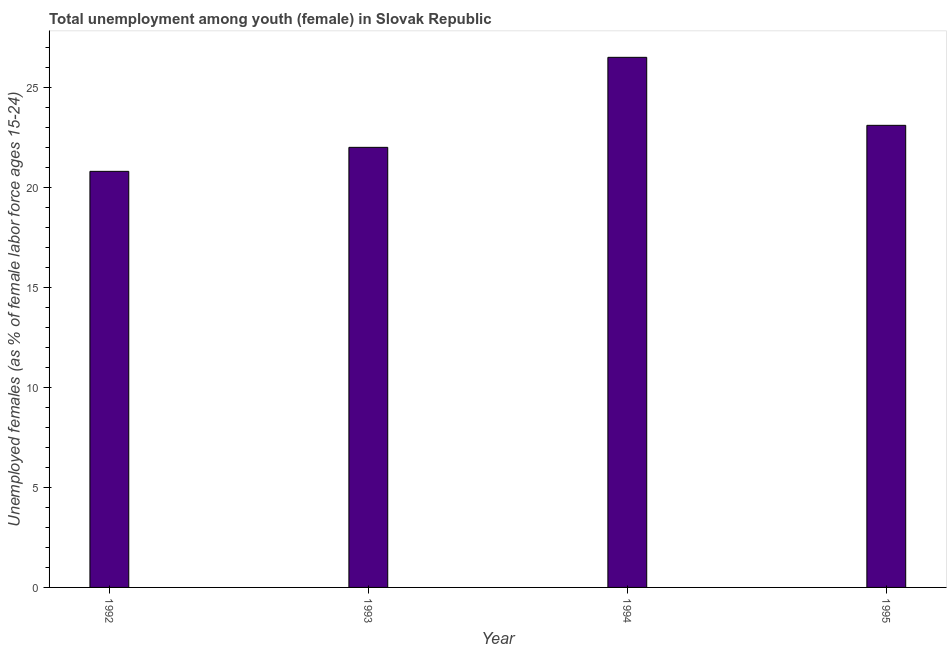Does the graph contain grids?
Provide a short and direct response. No. What is the title of the graph?
Your answer should be compact. Total unemployment among youth (female) in Slovak Republic. What is the label or title of the Y-axis?
Your answer should be compact. Unemployed females (as % of female labor force ages 15-24). What is the unemployed female youth population in 1992?
Offer a very short reply. 20.8. Across all years, what is the maximum unemployed female youth population?
Offer a terse response. 26.5. Across all years, what is the minimum unemployed female youth population?
Make the answer very short. 20.8. In which year was the unemployed female youth population maximum?
Make the answer very short. 1994. What is the sum of the unemployed female youth population?
Your response must be concise. 92.4. What is the average unemployed female youth population per year?
Ensure brevity in your answer.  23.1. What is the median unemployed female youth population?
Keep it short and to the point. 22.55. Is the unemployed female youth population in 1992 less than that in 1993?
Keep it short and to the point. Yes. What is the difference between the highest and the second highest unemployed female youth population?
Keep it short and to the point. 3.4. In how many years, is the unemployed female youth population greater than the average unemployed female youth population taken over all years?
Ensure brevity in your answer.  2. What is the difference between two consecutive major ticks on the Y-axis?
Your response must be concise. 5. Are the values on the major ticks of Y-axis written in scientific E-notation?
Your answer should be very brief. No. What is the Unemployed females (as % of female labor force ages 15-24) in 1992?
Give a very brief answer. 20.8. What is the Unemployed females (as % of female labor force ages 15-24) in 1993?
Ensure brevity in your answer.  22. What is the Unemployed females (as % of female labor force ages 15-24) of 1995?
Provide a succinct answer. 23.1. What is the difference between the Unemployed females (as % of female labor force ages 15-24) in 1993 and 1994?
Make the answer very short. -4.5. What is the ratio of the Unemployed females (as % of female labor force ages 15-24) in 1992 to that in 1993?
Ensure brevity in your answer.  0.94. What is the ratio of the Unemployed females (as % of female labor force ages 15-24) in 1992 to that in 1994?
Offer a very short reply. 0.79. What is the ratio of the Unemployed females (as % of female labor force ages 15-24) in 1992 to that in 1995?
Ensure brevity in your answer.  0.9. What is the ratio of the Unemployed females (as % of female labor force ages 15-24) in 1993 to that in 1994?
Your answer should be compact. 0.83. What is the ratio of the Unemployed females (as % of female labor force ages 15-24) in 1993 to that in 1995?
Your response must be concise. 0.95. What is the ratio of the Unemployed females (as % of female labor force ages 15-24) in 1994 to that in 1995?
Offer a terse response. 1.15. 